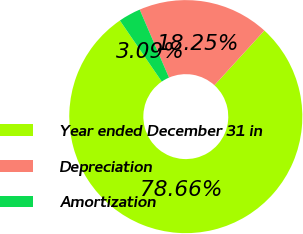<chart> <loc_0><loc_0><loc_500><loc_500><pie_chart><fcel>Year ended December 31 in<fcel>Depreciation<fcel>Amortization<nl><fcel>78.66%<fcel>18.25%<fcel>3.09%<nl></chart> 